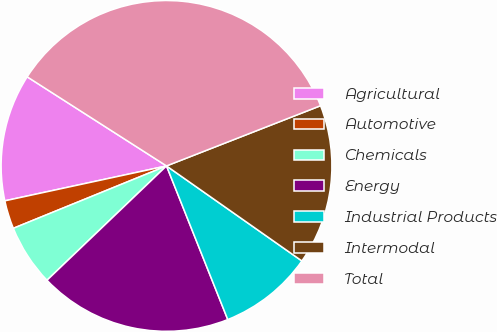<chart> <loc_0><loc_0><loc_500><loc_500><pie_chart><fcel>Agricultural<fcel>Automotive<fcel>Chemicals<fcel>Energy<fcel>Industrial Products<fcel>Intermodal<fcel>Total<nl><fcel>12.44%<fcel>2.77%<fcel>5.99%<fcel>18.89%<fcel>9.22%<fcel>15.67%<fcel>35.01%<nl></chart> 